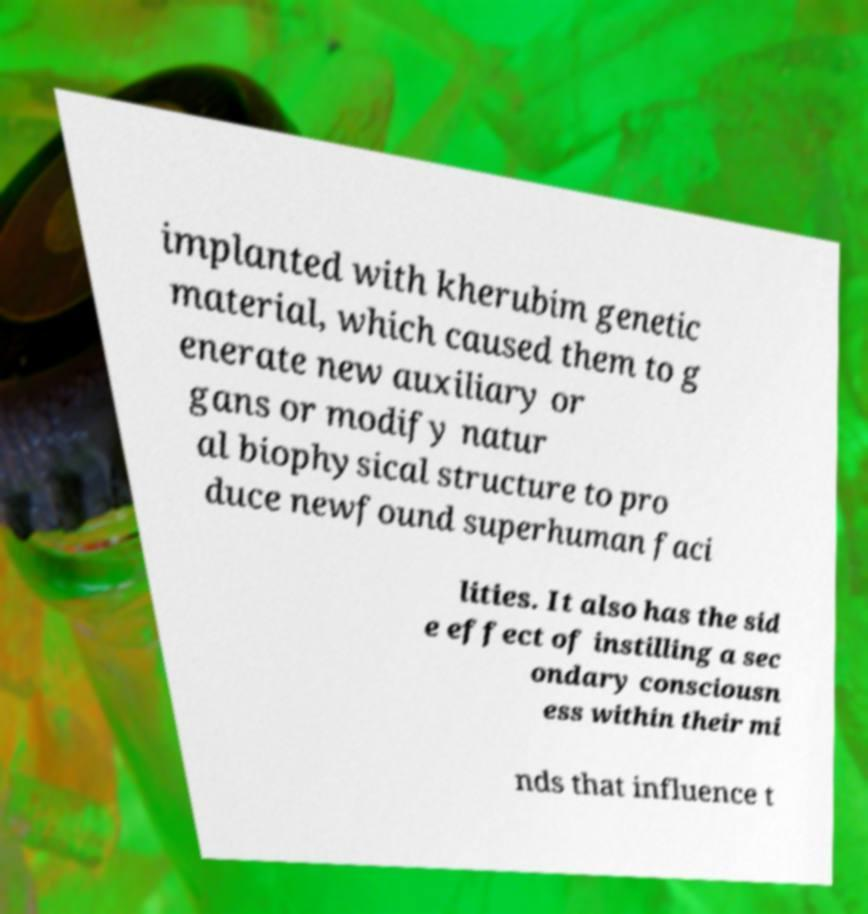I need the written content from this picture converted into text. Can you do that? implanted with kherubim genetic material, which caused them to g enerate new auxiliary or gans or modify natur al biophysical structure to pro duce newfound superhuman faci lities. It also has the sid e effect of instilling a sec ondary consciousn ess within their mi nds that influence t 